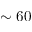<formula> <loc_0><loc_0><loc_500><loc_500>\sim 6 0</formula> 